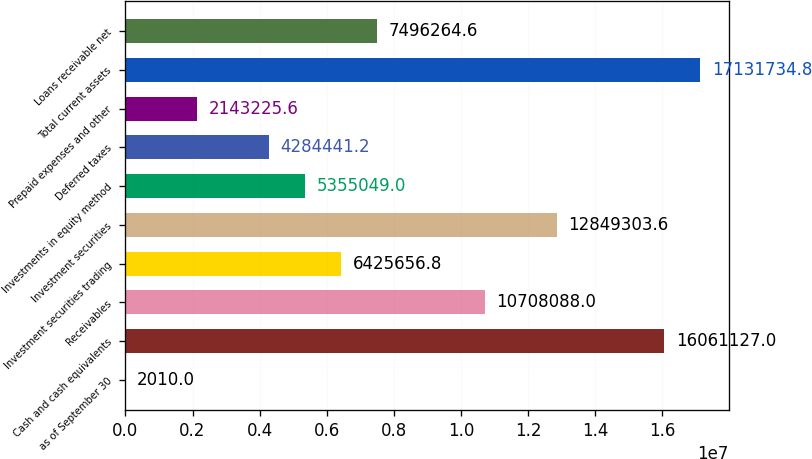<chart> <loc_0><loc_0><loc_500><loc_500><bar_chart><fcel>as of September 30<fcel>Cash and cash equivalents<fcel>Receivables<fcel>Investment securities trading<fcel>Investment securities<fcel>Investments in equity method<fcel>Deferred taxes<fcel>Prepaid expenses and other<fcel>Total current assets<fcel>Loans receivable net<nl><fcel>2010<fcel>1.60611e+07<fcel>1.07081e+07<fcel>6.42566e+06<fcel>1.28493e+07<fcel>5.35505e+06<fcel>4.28444e+06<fcel>2.14323e+06<fcel>1.71317e+07<fcel>7.49626e+06<nl></chart> 